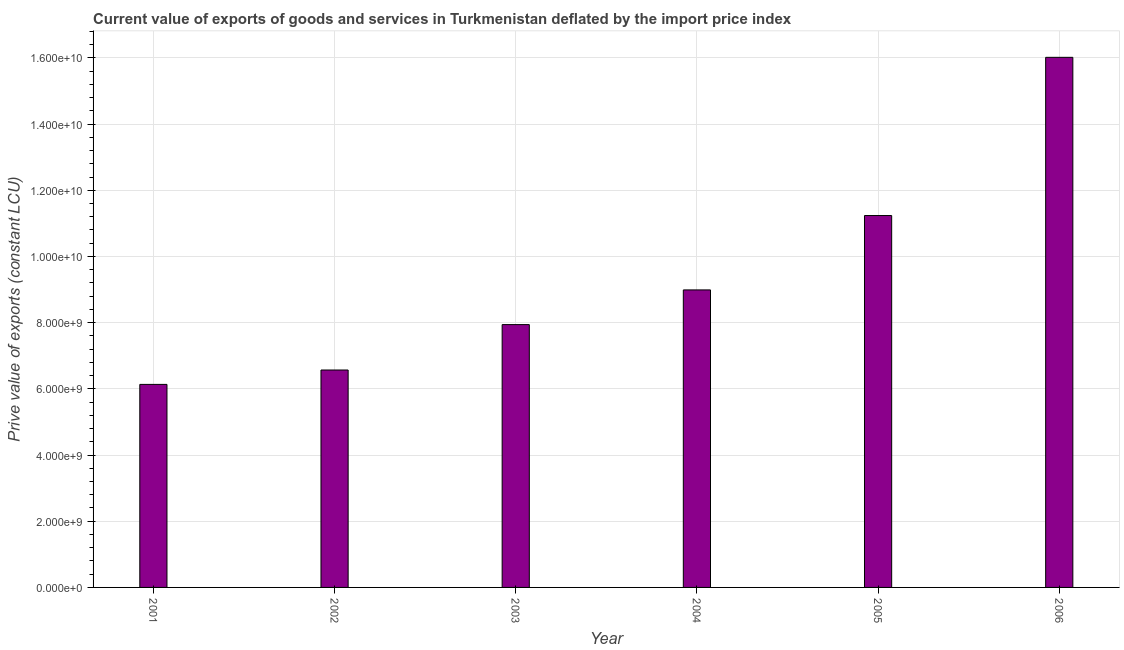Does the graph contain any zero values?
Your answer should be compact. No. Does the graph contain grids?
Your response must be concise. Yes. What is the title of the graph?
Your response must be concise. Current value of exports of goods and services in Turkmenistan deflated by the import price index. What is the label or title of the Y-axis?
Your answer should be compact. Prive value of exports (constant LCU). What is the price value of exports in 2003?
Offer a very short reply. 7.94e+09. Across all years, what is the maximum price value of exports?
Your response must be concise. 1.60e+1. Across all years, what is the minimum price value of exports?
Provide a short and direct response. 6.13e+09. In which year was the price value of exports minimum?
Your answer should be compact. 2001. What is the sum of the price value of exports?
Give a very brief answer. 5.69e+1. What is the difference between the price value of exports in 2001 and 2005?
Your answer should be compact. -5.10e+09. What is the average price value of exports per year?
Keep it short and to the point. 9.48e+09. What is the median price value of exports?
Your answer should be compact. 8.46e+09. In how many years, is the price value of exports greater than 3600000000 LCU?
Give a very brief answer. 6. Do a majority of the years between 2001 and 2005 (inclusive) have price value of exports greater than 12000000000 LCU?
Your response must be concise. No. What is the ratio of the price value of exports in 2004 to that in 2006?
Your answer should be very brief. 0.56. What is the difference between the highest and the second highest price value of exports?
Make the answer very short. 4.78e+09. What is the difference between the highest and the lowest price value of exports?
Offer a very short reply. 9.88e+09. How many bars are there?
Your response must be concise. 6. What is the difference between two consecutive major ticks on the Y-axis?
Offer a very short reply. 2.00e+09. What is the Prive value of exports (constant LCU) of 2001?
Ensure brevity in your answer.  6.13e+09. What is the Prive value of exports (constant LCU) of 2002?
Offer a very short reply. 6.57e+09. What is the Prive value of exports (constant LCU) in 2003?
Offer a very short reply. 7.94e+09. What is the Prive value of exports (constant LCU) in 2004?
Make the answer very short. 8.99e+09. What is the Prive value of exports (constant LCU) in 2005?
Offer a very short reply. 1.12e+1. What is the Prive value of exports (constant LCU) in 2006?
Your response must be concise. 1.60e+1. What is the difference between the Prive value of exports (constant LCU) in 2001 and 2002?
Make the answer very short. -4.35e+08. What is the difference between the Prive value of exports (constant LCU) in 2001 and 2003?
Keep it short and to the point. -1.81e+09. What is the difference between the Prive value of exports (constant LCU) in 2001 and 2004?
Give a very brief answer. -2.85e+09. What is the difference between the Prive value of exports (constant LCU) in 2001 and 2005?
Keep it short and to the point. -5.10e+09. What is the difference between the Prive value of exports (constant LCU) in 2001 and 2006?
Give a very brief answer. -9.88e+09. What is the difference between the Prive value of exports (constant LCU) in 2002 and 2003?
Offer a very short reply. -1.37e+09. What is the difference between the Prive value of exports (constant LCU) in 2002 and 2004?
Give a very brief answer. -2.42e+09. What is the difference between the Prive value of exports (constant LCU) in 2002 and 2005?
Your answer should be compact. -4.67e+09. What is the difference between the Prive value of exports (constant LCU) in 2002 and 2006?
Your response must be concise. -9.45e+09. What is the difference between the Prive value of exports (constant LCU) in 2003 and 2004?
Provide a succinct answer. -1.05e+09. What is the difference between the Prive value of exports (constant LCU) in 2003 and 2005?
Provide a short and direct response. -3.30e+09. What is the difference between the Prive value of exports (constant LCU) in 2003 and 2006?
Give a very brief answer. -8.07e+09. What is the difference between the Prive value of exports (constant LCU) in 2004 and 2005?
Keep it short and to the point. -2.25e+09. What is the difference between the Prive value of exports (constant LCU) in 2004 and 2006?
Provide a succinct answer. -7.03e+09. What is the difference between the Prive value of exports (constant LCU) in 2005 and 2006?
Make the answer very short. -4.78e+09. What is the ratio of the Prive value of exports (constant LCU) in 2001 to that in 2002?
Your answer should be very brief. 0.93. What is the ratio of the Prive value of exports (constant LCU) in 2001 to that in 2003?
Your answer should be compact. 0.77. What is the ratio of the Prive value of exports (constant LCU) in 2001 to that in 2004?
Offer a terse response. 0.68. What is the ratio of the Prive value of exports (constant LCU) in 2001 to that in 2005?
Your answer should be very brief. 0.55. What is the ratio of the Prive value of exports (constant LCU) in 2001 to that in 2006?
Keep it short and to the point. 0.38. What is the ratio of the Prive value of exports (constant LCU) in 2002 to that in 2003?
Offer a very short reply. 0.83. What is the ratio of the Prive value of exports (constant LCU) in 2002 to that in 2004?
Your answer should be very brief. 0.73. What is the ratio of the Prive value of exports (constant LCU) in 2002 to that in 2005?
Offer a terse response. 0.58. What is the ratio of the Prive value of exports (constant LCU) in 2002 to that in 2006?
Provide a short and direct response. 0.41. What is the ratio of the Prive value of exports (constant LCU) in 2003 to that in 2004?
Your response must be concise. 0.88. What is the ratio of the Prive value of exports (constant LCU) in 2003 to that in 2005?
Offer a very short reply. 0.71. What is the ratio of the Prive value of exports (constant LCU) in 2003 to that in 2006?
Give a very brief answer. 0.5. What is the ratio of the Prive value of exports (constant LCU) in 2004 to that in 2006?
Provide a succinct answer. 0.56. What is the ratio of the Prive value of exports (constant LCU) in 2005 to that in 2006?
Your answer should be compact. 0.7. 